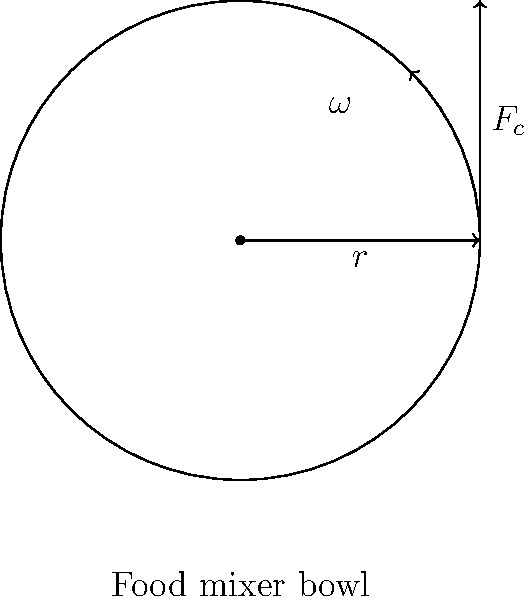In your plant-based bakery, you're using a food mixer to blend ingredients for a vegan cake. The mixer's bowl has a radius of 0.15 m, and it rotates at 120 rpm (revolutions per minute). If a small piece of dough with a mass of 10 g is stuck to the side of the bowl, what is the magnitude of the centripetal force acting on it? Let's approach this step-by-step:

1) First, we need to convert the angular velocity from rpm to rad/s:
   $\omega = 120 \text{ rpm} \times \frac{2\pi \text{ rad}}{1 \text{ rev}} \times \frac{1 \text{ min}}{60 \text{ s}} = 4\pi \text{ rad/s}$

2) The formula for centripetal force is:
   $F_c = m\omega^2r$

   Where:
   $F_c$ is the centripetal force
   $m$ is the mass of the object
   $\omega$ is the angular velocity
   $r$ is the radius of circular motion

3) We have:
   $m = 10 \text{ g} = 0.01 \text{ kg}$
   $\omega = 4\pi \text{ rad/s}$
   $r = 0.15 \text{ m}$

4) Let's substitute these values into our formula:
   $F_c = 0.01 \text{ kg} \times (4\pi \text{ rad/s})^2 \times 0.15 \text{ m}$

5) Calculate:
   $F_c = 0.01 \times 16\pi^2 \times 0.15 = 0.24\pi^2 \approx 2.37 \text{ N}$

Therefore, the magnitude of the centripetal force acting on the piece of dough is approximately 2.37 N.
Answer: 2.37 N 